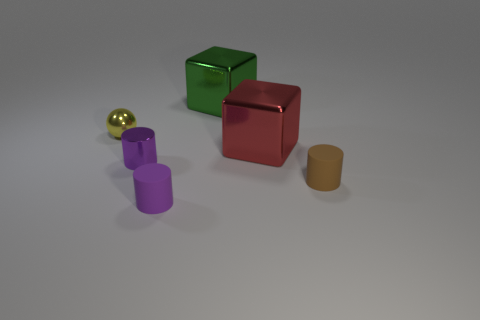Add 1 large gray objects. How many objects exist? 7 Subtract all cubes. How many objects are left? 4 Add 4 small metallic spheres. How many small metallic spheres are left? 5 Add 4 green blocks. How many green blocks exist? 5 Subtract 0 purple cubes. How many objects are left? 6 Subtract all red metal things. Subtract all small brown matte things. How many objects are left? 4 